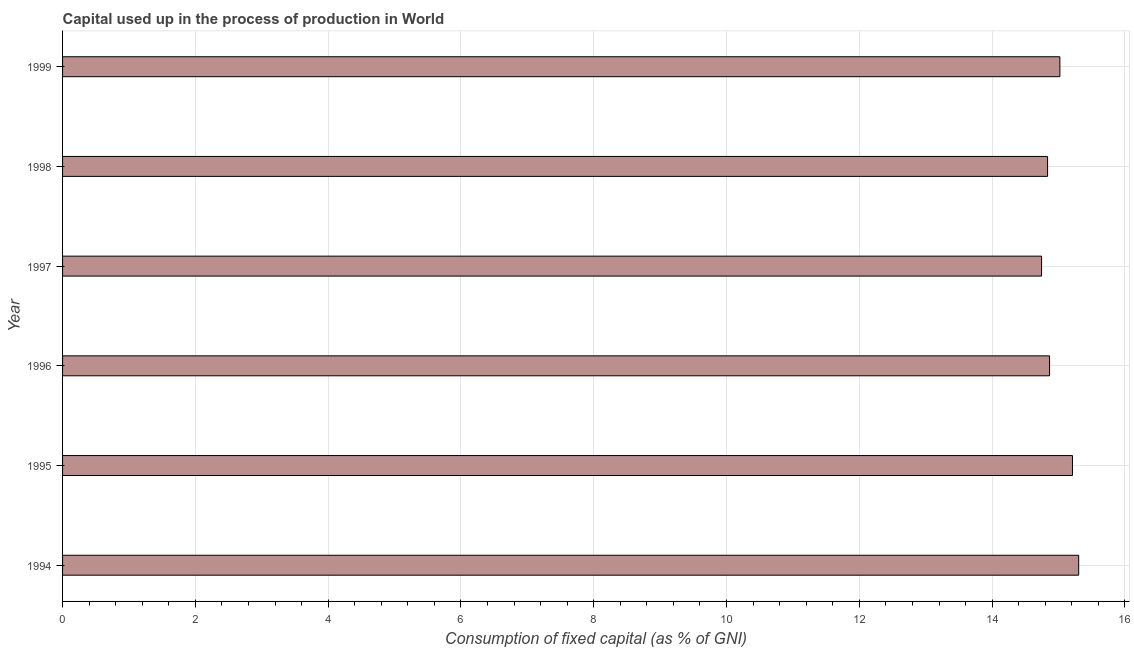Does the graph contain any zero values?
Offer a terse response. No. Does the graph contain grids?
Ensure brevity in your answer.  Yes. What is the title of the graph?
Your answer should be very brief. Capital used up in the process of production in World. What is the label or title of the X-axis?
Your answer should be compact. Consumption of fixed capital (as % of GNI). What is the label or title of the Y-axis?
Ensure brevity in your answer.  Year. What is the consumption of fixed capital in 1998?
Make the answer very short. 14.84. Across all years, what is the maximum consumption of fixed capital?
Your answer should be very brief. 15.3. Across all years, what is the minimum consumption of fixed capital?
Offer a very short reply. 14.74. In which year was the consumption of fixed capital minimum?
Your response must be concise. 1997. What is the sum of the consumption of fixed capital?
Provide a short and direct response. 89.98. What is the difference between the consumption of fixed capital in 1997 and 1999?
Your answer should be compact. -0.28. What is the average consumption of fixed capital per year?
Provide a short and direct response. 15. What is the median consumption of fixed capital?
Your answer should be very brief. 14.94. What is the ratio of the consumption of fixed capital in 1998 to that in 1999?
Offer a very short reply. 0.99. Is the difference between the consumption of fixed capital in 1995 and 1998 greater than the difference between any two years?
Your answer should be very brief. No. What is the difference between the highest and the second highest consumption of fixed capital?
Give a very brief answer. 0.09. Is the sum of the consumption of fixed capital in 1998 and 1999 greater than the maximum consumption of fixed capital across all years?
Provide a short and direct response. Yes. What is the difference between the highest and the lowest consumption of fixed capital?
Make the answer very short. 0.56. What is the Consumption of fixed capital (as % of GNI) in 1994?
Offer a terse response. 15.3. What is the Consumption of fixed capital (as % of GNI) in 1995?
Keep it short and to the point. 15.21. What is the Consumption of fixed capital (as % of GNI) of 1996?
Offer a very short reply. 14.86. What is the Consumption of fixed capital (as % of GNI) in 1997?
Offer a terse response. 14.74. What is the Consumption of fixed capital (as % of GNI) of 1998?
Keep it short and to the point. 14.84. What is the Consumption of fixed capital (as % of GNI) in 1999?
Your answer should be compact. 15.02. What is the difference between the Consumption of fixed capital (as % of GNI) in 1994 and 1995?
Provide a succinct answer. 0.09. What is the difference between the Consumption of fixed capital (as % of GNI) in 1994 and 1996?
Provide a succinct answer. 0.44. What is the difference between the Consumption of fixed capital (as % of GNI) in 1994 and 1997?
Make the answer very short. 0.56. What is the difference between the Consumption of fixed capital (as % of GNI) in 1994 and 1998?
Offer a terse response. 0.47. What is the difference between the Consumption of fixed capital (as % of GNI) in 1994 and 1999?
Offer a very short reply. 0.28. What is the difference between the Consumption of fixed capital (as % of GNI) in 1995 and 1996?
Keep it short and to the point. 0.34. What is the difference between the Consumption of fixed capital (as % of GNI) in 1995 and 1997?
Offer a very short reply. 0.47. What is the difference between the Consumption of fixed capital (as % of GNI) in 1995 and 1998?
Offer a very short reply. 0.37. What is the difference between the Consumption of fixed capital (as % of GNI) in 1995 and 1999?
Offer a very short reply. 0.19. What is the difference between the Consumption of fixed capital (as % of GNI) in 1996 and 1997?
Provide a succinct answer. 0.12. What is the difference between the Consumption of fixed capital (as % of GNI) in 1996 and 1998?
Offer a very short reply. 0.03. What is the difference between the Consumption of fixed capital (as % of GNI) in 1996 and 1999?
Provide a succinct answer. -0.16. What is the difference between the Consumption of fixed capital (as % of GNI) in 1997 and 1998?
Ensure brevity in your answer.  -0.09. What is the difference between the Consumption of fixed capital (as % of GNI) in 1997 and 1999?
Your answer should be very brief. -0.28. What is the difference between the Consumption of fixed capital (as % of GNI) in 1998 and 1999?
Make the answer very short. -0.19. What is the ratio of the Consumption of fixed capital (as % of GNI) in 1994 to that in 1995?
Provide a short and direct response. 1.01. What is the ratio of the Consumption of fixed capital (as % of GNI) in 1994 to that in 1996?
Give a very brief answer. 1.03. What is the ratio of the Consumption of fixed capital (as % of GNI) in 1994 to that in 1997?
Keep it short and to the point. 1.04. What is the ratio of the Consumption of fixed capital (as % of GNI) in 1994 to that in 1998?
Provide a succinct answer. 1.03. What is the ratio of the Consumption of fixed capital (as % of GNI) in 1995 to that in 1997?
Offer a terse response. 1.03. What is the ratio of the Consumption of fixed capital (as % of GNI) in 1995 to that in 1998?
Ensure brevity in your answer.  1.02. What is the ratio of the Consumption of fixed capital (as % of GNI) in 1995 to that in 1999?
Your answer should be very brief. 1.01. What is the ratio of the Consumption of fixed capital (as % of GNI) in 1996 to that in 1998?
Your answer should be very brief. 1. What is the ratio of the Consumption of fixed capital (as % of GNI) in 1996 to that in 1999?
Your answer should be compact. 0.99. 